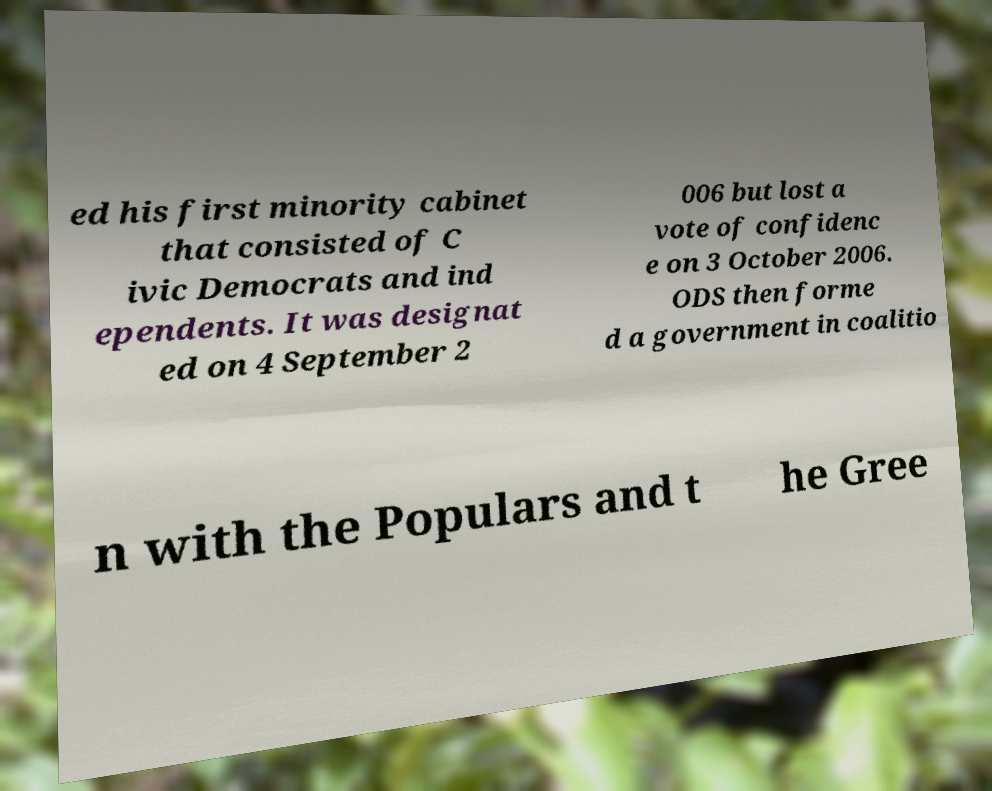Can you accurately transcribe the text from the provided image for me? ed his first minority cabinet that consisted of C ivic Democrats and ind ependents. It was designat ed on 4 September 2 006 but lost a vote of confidenc e on 3 October 2006. ODS then forme d a government in coalitio n with the Populars and t he Gree 